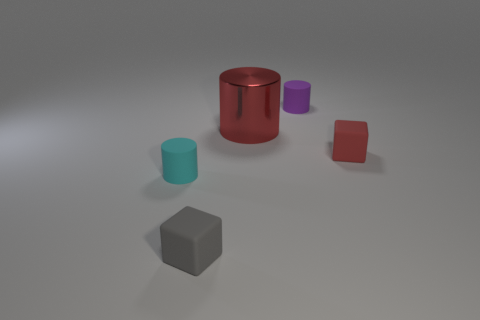There is a red object that is to the right of the red shiny cylinder; does it have the same shape as the tiny rubber object behind the big metallic object?
Provide a short and direct response. No. How many tiny rubber cubes are in front of the tiny cyan rubber cylinder and behind the small cyan matte object?
Your answer should be compact. 0. Is there another large metal thing of the same color as the big thing?
Your response must be concise. No. The red object that is the same size as the purple rubber cylinder is what shape?
Offer a very short reply. Cube. Are there any red matte things in front of the gray rubber object?
Give a very brief answer. No. Are the cube that is behind the cyan matte thing and the small gray block that is left of the large red object made of the same material?
Give a very brief answer. Yes. What number of gray blocks are the same size as the cyan matte cylinder?
Your response must be concise. 1. There is a tiny object that is the same color as the large metal object; what is its shape?
Your answer should be compact. Cube. What is the small cube to the right of the large thing made of?
Keep it short and to the point. Rubber. How many other red matte things are the same shape as the tiny red thing?
Give a very brief answer. 0. 